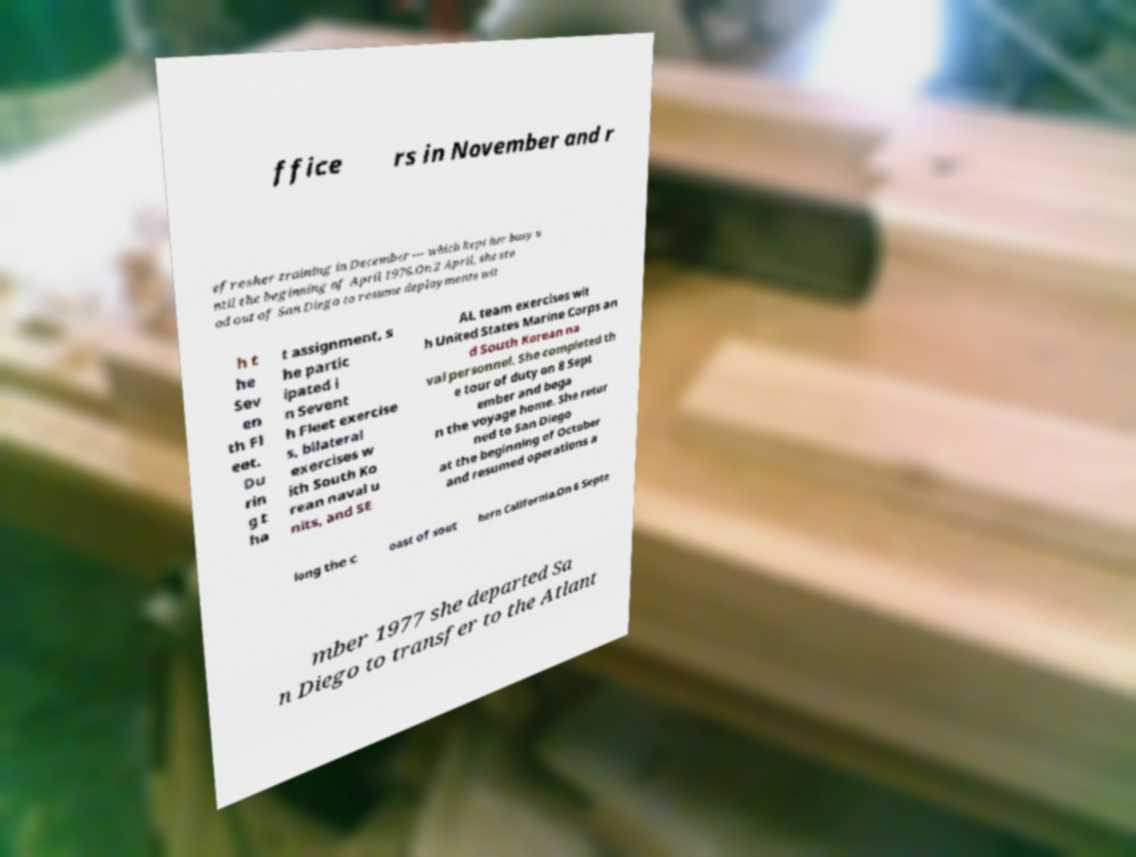Can you read and provide the text displayed in the image?This photo seems to have some interesting text. Can you extract and type it out for me? ffice rs in November and r efresher training in December — which kept her busy u ntil the beginning of April 1976.On 2 April, she sto od out of San Diego to resume deployments wit h t he Sev en th Fl eet. Du rin g t ha t assignment, s he partic ipated i n Sevent h Fleet exercise s, bilateral exercises w ith South Ko rean naval u nits, and SE AL team exercises wit h United States Marine Corps an d South Korean na val personnel. She completed th e tour of duty on 8 Sept ember and bega n the voyage home. She retur ned to San Diego at the beginning of October and resumed operations a long the c oast of sout hern California.On 6 Septe mber 1977 she departed Sa n Diego to transfer to the Atlant 